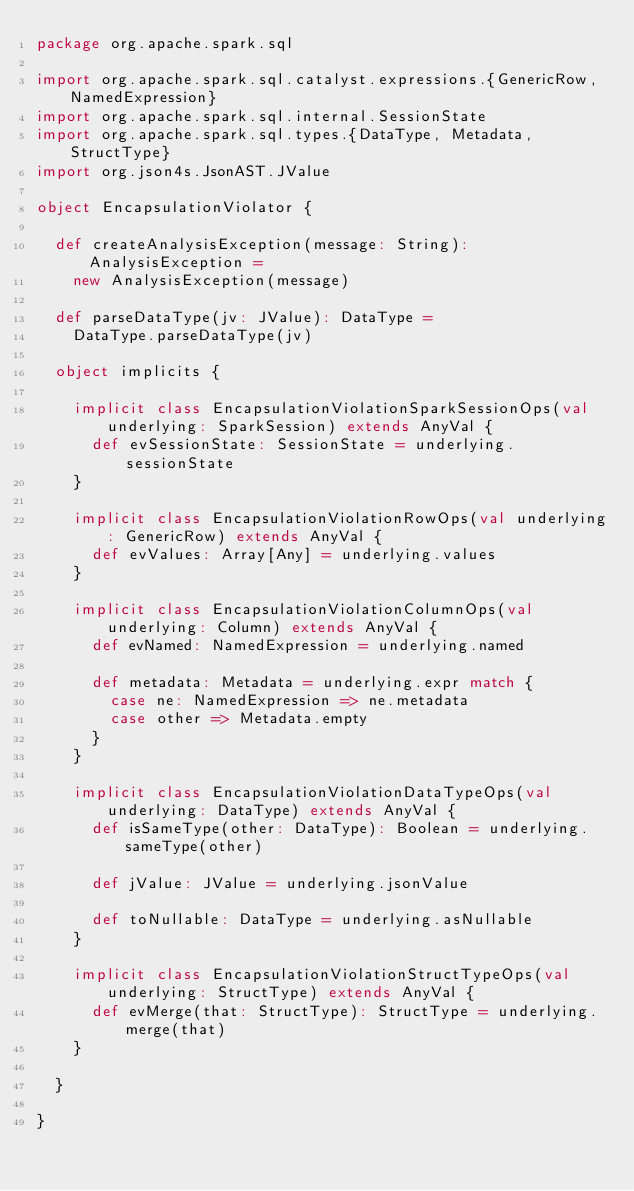Convert code to text. <code><loc_0><loc_0><loc_500><loc_500><_Scala_>package org.apache.spark.sql

import org.apache.spark.sql.catalyst.expressions.{GenericRow, NamedExpression}
import org.apache.spark.sql.internal.SessionState
import org.apache.spark.sql.types.{DataType, Metadata, StructType}
import org.json4s.JsonAST.JValue

object EncapsulationViolator {

  def createAnalysisException(message: String): AnalysisException =
    new AnalysisException(message)

  def parseDataType(jv: JValue): DataType =
    DataType.parseDataType(jv)

  object implicits {

    implicit class EncapsulationViolationSparkSessionOps(val underlying: SparkSession) extends AnyVal {
      def evSessionState: SessionState = underlying.sessionState
    }

    implicit class EncapsulationViolationRowOps(val underlying: GenericRow) extends AnyVal {
      def evValues: Array[Any] = underlying.values
    }

    implicit class EncapsulationViolationColumnOps(val underlying: Column) extends AnyVal {
      def evNamed: NamedExpression = underlying.named

      def metadata: Metadata = underlying.expr match {
        case ne: NamedExpression => ne.metadata
        case other => Metadata.empty
      }
    }

    implicit class EncapsulationViolationDataTypeOps(val underlying: DataType) extends AnyVal {
      def isSameType(other: DataType): Boolean = underlying.sameType(other)

      def jValue: JValue = underlying.jsonValue

      def toNullable: DataType = underlying.asNullable
    }

    implicit class EncapsulationViolationStructTypeOps(val underlying: StructType) extends AnyVal {
      def evMerge(that: StructType): StructType = underlying.merge(that)
    }

  }

}
</code> 